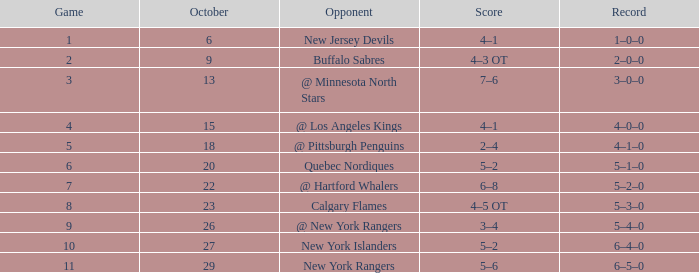Parse the full table. {'header': ['Game', 'October', 'Opponent', 'Score', 'Record'], 'rows': [['1', '6', 'New Jersey Devils', '4–1', '1–0–0'], ['2', '9', 'Buffalo Sabres', '4–3 OT', '2–0–0'], ['3', '13', '@ Minnesota North Stars', '7–6', '3–0–0'], ['4', '15', '@ Los Angeles Kings', '4–1', '4–0–0'], ['5', '18', '@ Pittsburgh Penguins', '2–4', '4–1–0'], ['6', '20', 'Quebec Nordiques', '5–2', '5–1–0'], ['7', '22', '@ Hartford Whalers', '6–8', '5–2–0'], ['8', '23', 'Calgary Flames', '4–5 OT', '5–3–0'], ['9', '26', '@ New York Rangers', '3–4', '5–4–0'], ['10', '27', 'New York Islanders', '5–2', '6–4–0'], ['11', '29', 'New York Rangers', '5–6', '6–5–0']]} Which October has a Record of 5–1–0, and a Game larger than 6? None. 